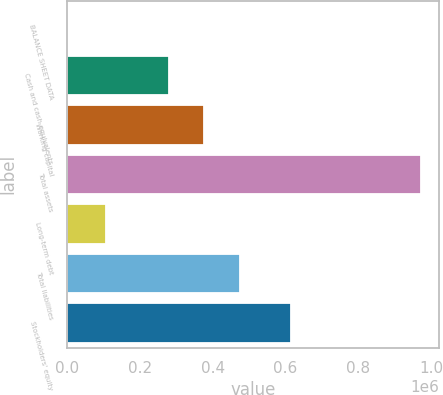Convert chart to OTSL. <chart><loc_0><loc_0><loc_500><loc_500><bar_chart><fcel>BALANCE SHEET DATA<fcel>Cash and cash equivalents<fcel>Working capital<fcel>Total assets<fcel>Long-term debt<fcel>Total liabilities<fcel>Stockholders' equity<nl><fcel>2011<fcel>280359<fcel>377324<fcel>971659<fcel>107239<fcel>474289<fcel>615279<nl></chart> 